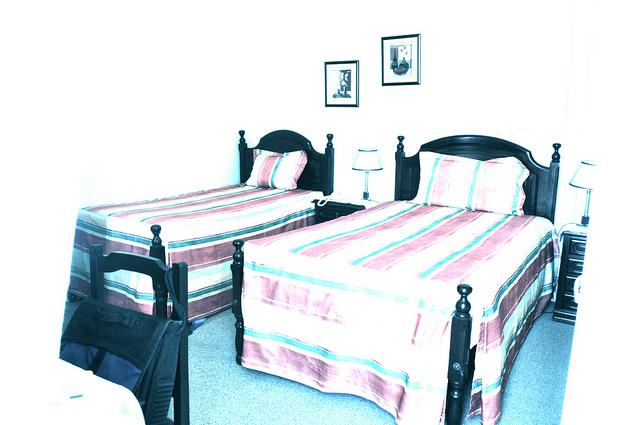How many people can sleep in this room? Please explain your reasoning. two. These are twin size beds that are used for one person each 